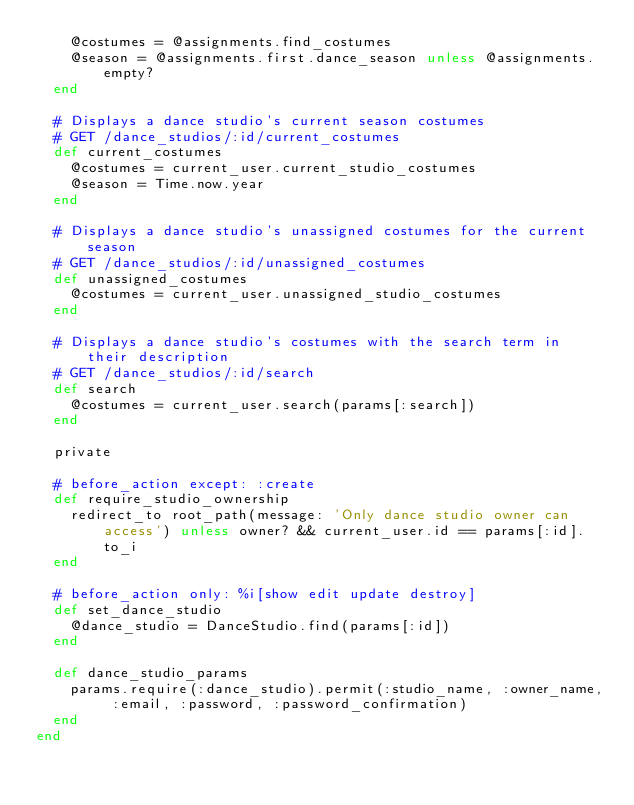<code> <loc_0><loc_0><loc_500><loc_500><_Ruby_>    @costumes = @assignments.find_costumes
    @season = @assignments.first.dance_season unless @assignments.empty?
  end

  # Displays a dance studio's current season costumes
  # GET /dance_studios/:id/current_costumes
  def current_costumes
    @costumes = current_user.current_studio_costumes
    @season = Time.now.year
  end

  # Displays a dance studio's unassigned costumes for the current season
  # GET /dance_studios/:id/unassigned_costumes
  def unassigned_costumes
    @costumes = current_user.unassigned_studio_costumes
  end

  # Displays a dance studio's costumes with the search term in their description
  # GET /dance_studios/:id/search
  def search
    @costumes = current_user.search(params[:search])
  end

  private

  # before_action except: :create
  def require_studio_ownership
    redirect_to root_path(message: 'Only dance studio owner can access') unless owner? && current_user.id == params[:id].to_i
  end

  # before_action only: %i[show edit update destroy]
  def set_dance_studio
    @dance_studio = DanceStudio.find(params[:id])
  end

  def dance_studio_params
    params.require(:dance_studio).permit(:studio_name, :owner_name, :email, :password, :password_confirmation)
  end
end
</code> 